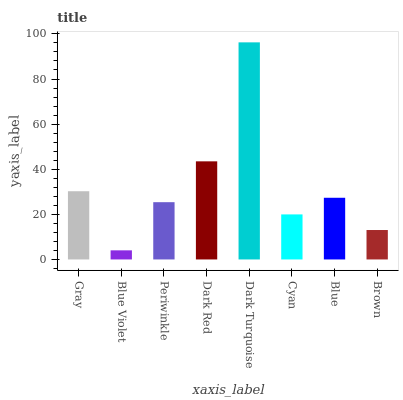Is Blue Violet the minimum?
Answer yes or no. Yes. Is Dark Turquoise the maximum?
Answer yes or no. Yes. Is Periwinkle the minimum?
Answer yes or no. No. Is Periwinkle the maximum?
Answer yes or no. No. Is Periwinkle greater than Blue Violet?
Answer yes or no. Yes. Is Blue Violet less than Periwinkle?
Answer yes or no. Yes. Is Blue Violet greater than Periwinkle?
Answer yes or no. No. Is Periwinkle less than Blue Violet?
Answer yes or no. No. Is Blue the high median?
Answer yes or no. Yes. Is Periwinkle the low median?
Answer yes or no. Yes. Is Cyan the high median?
Answer yes or no. No. Is Dark Red the low median?
Answer yes or no. No. 